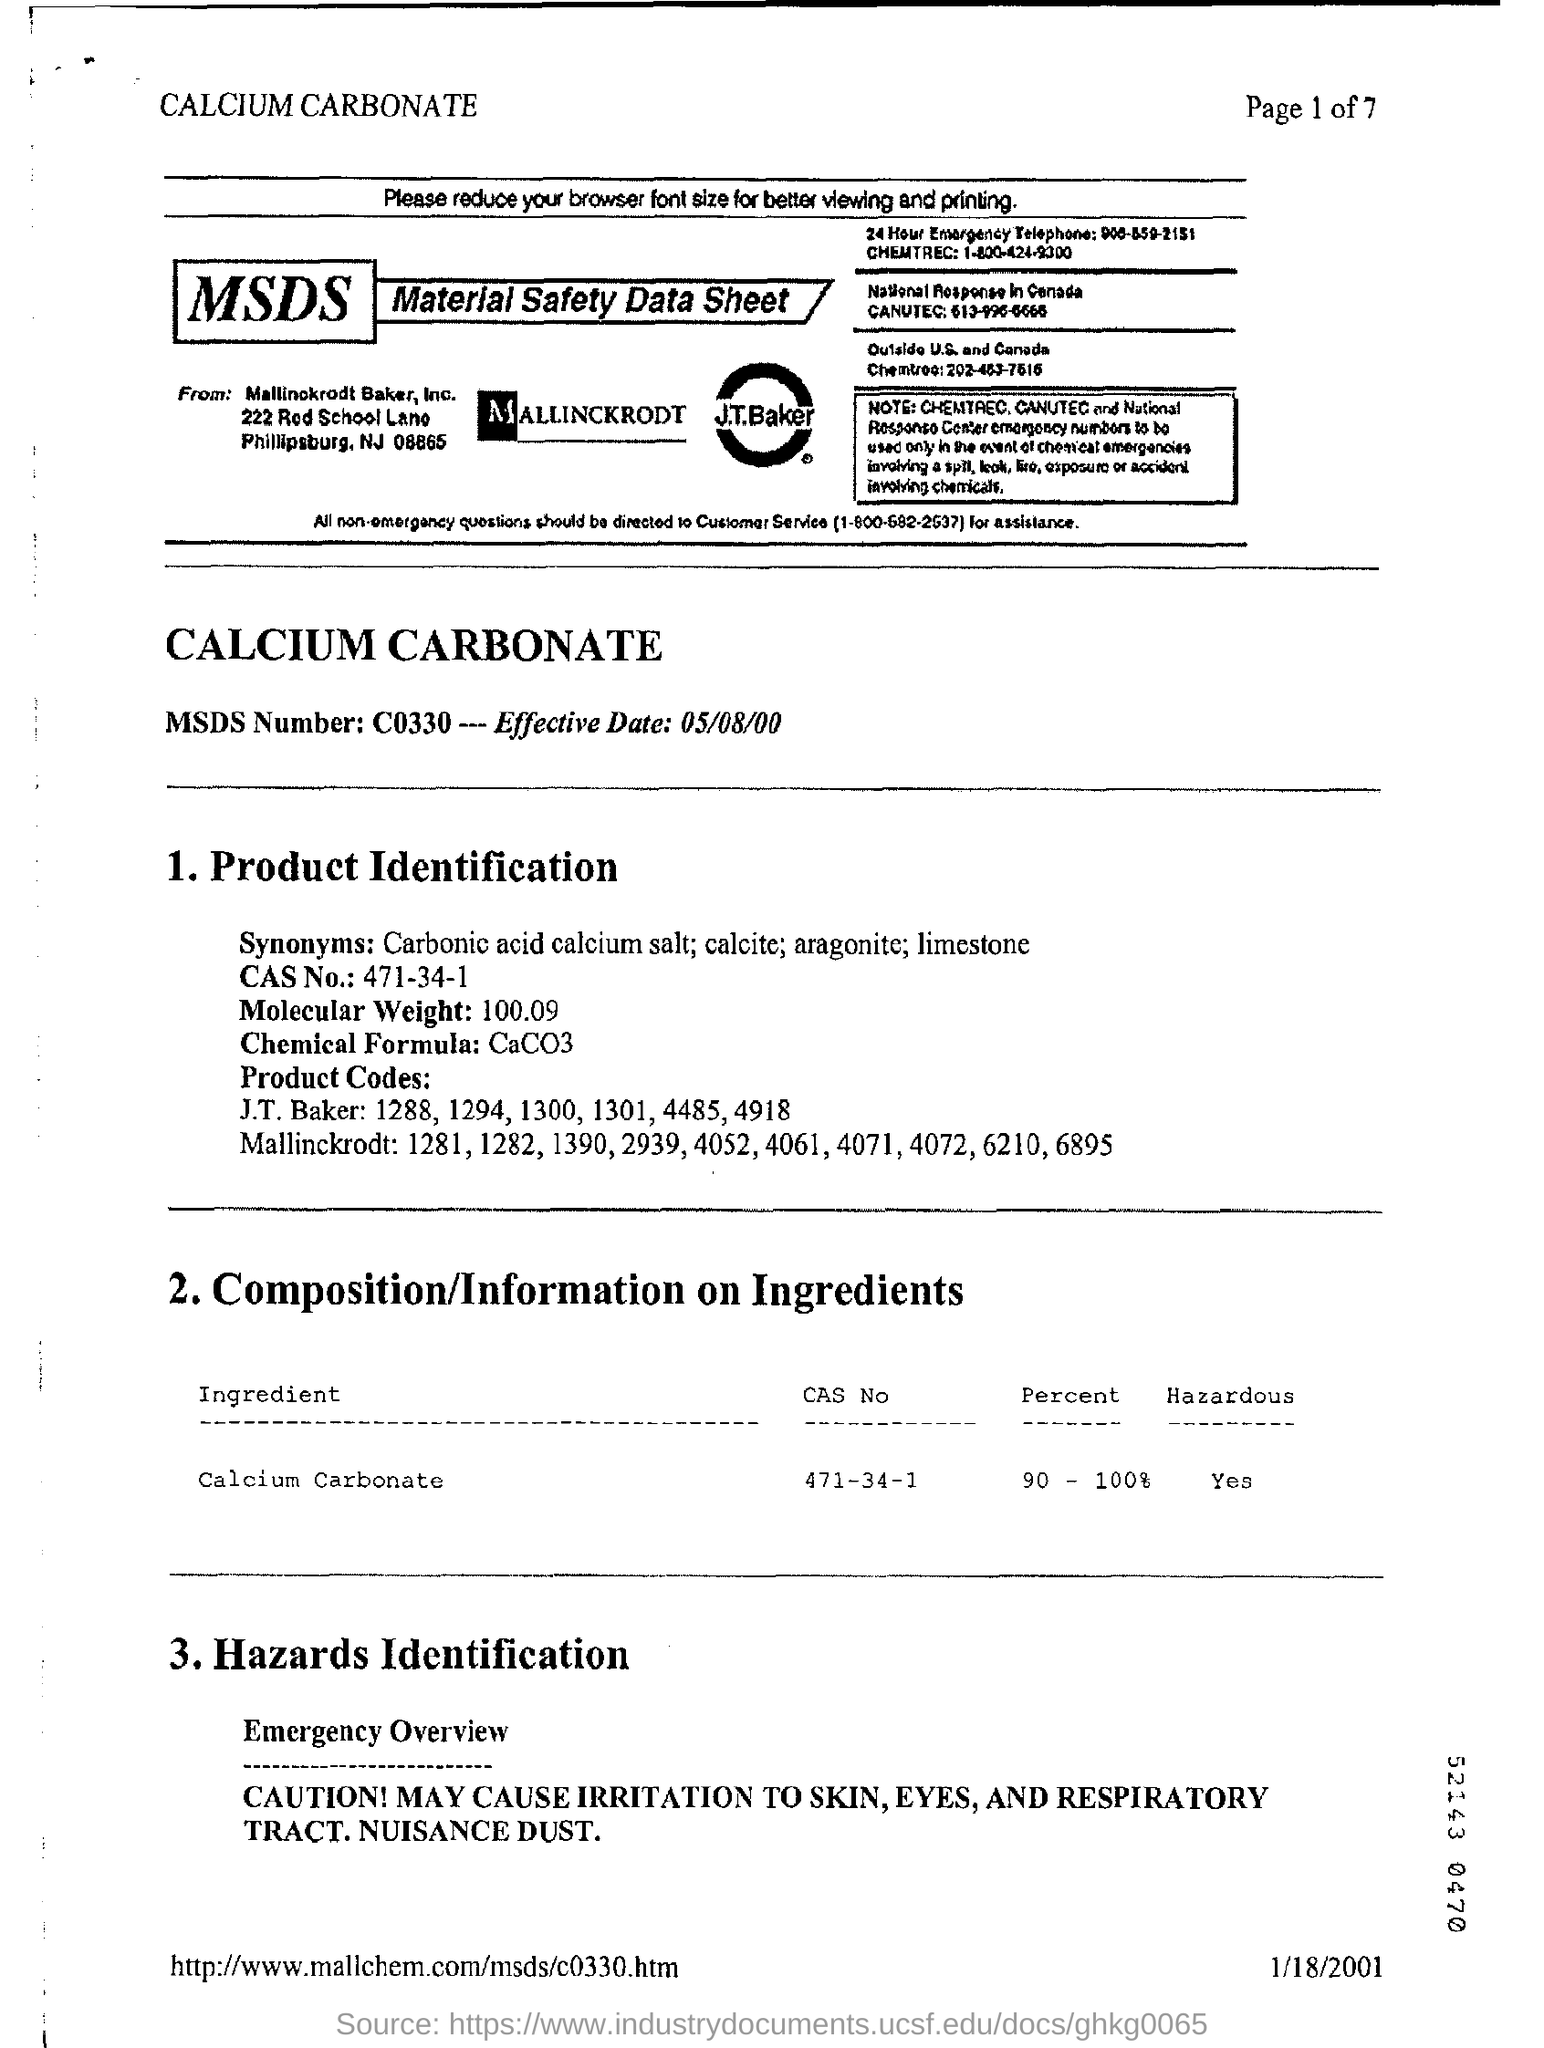What is the MSDS Numer?
Offer a terse response. C0330. What is the Effective Date?
Your response must be concise. 05/08/00. What is the CAS NO.?
Offer a very short reply. 471-34-1. What is the Molecular Weight?
Offer a terse response. 100.09. What is the Chemical Formula?
Your answer should be very brief. CaCO3. What is the Ingredient?
Your response must be concise. Calcium Carbonate. What is the Percent of Calcium Carbonate ?
Make the answer very short. 90 - 100%. Is Calcium Carbonate Hazardous?
Offer a terse response. Yes. 